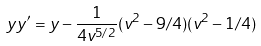Convert formula to latex. <formula><loc_0><loc_0><loc_500><loc_500>y y ^ { \prime } = y - \frac { 1 } { 4 v ^ { 5 / 2 } } ( v ^ { 2 } - 9 / 4 ) ( v ^ { 2 } - 1 / 4 )</formula> 